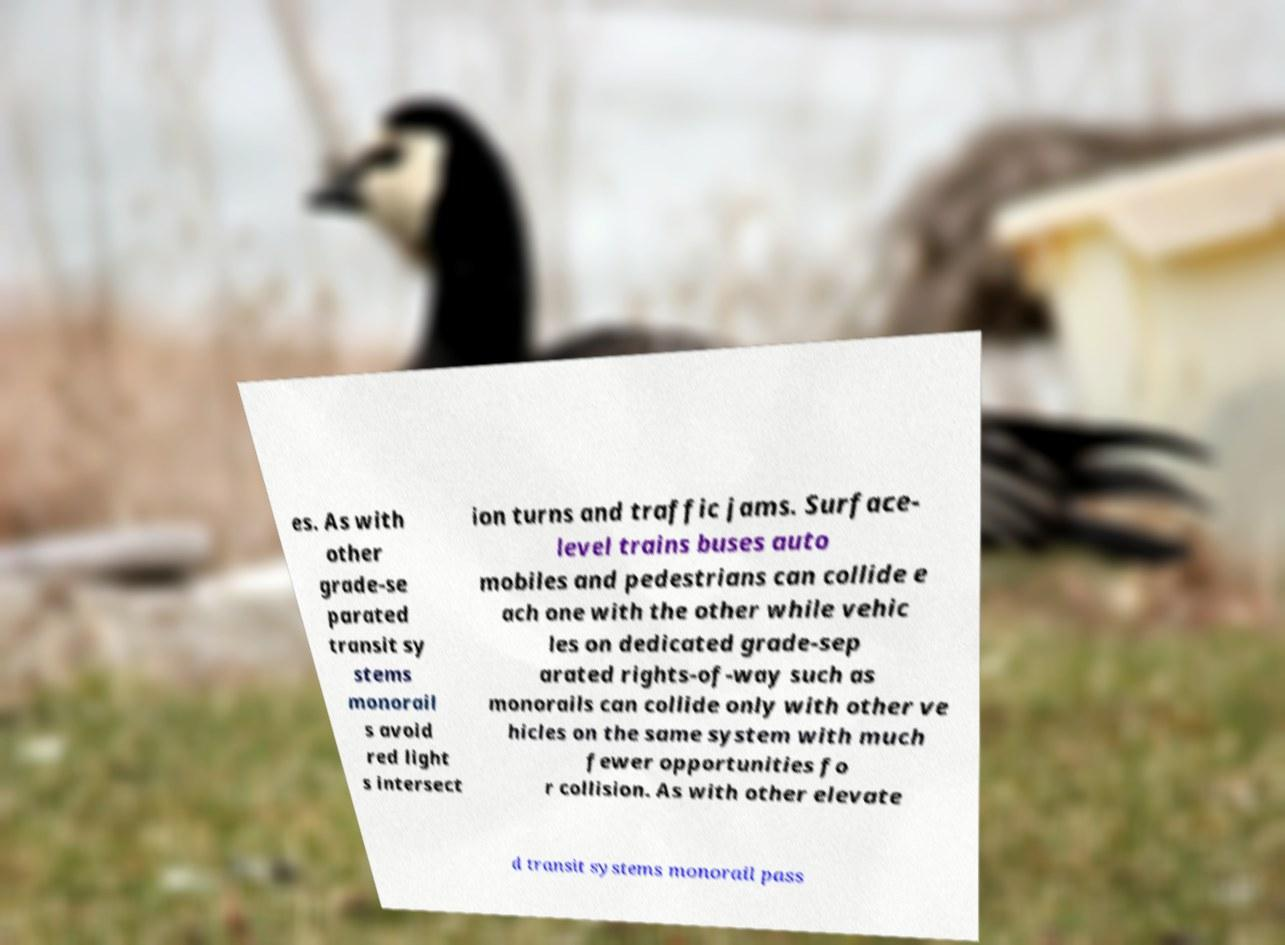For documentation purposes, I need the text within this image transcribed. Could you provide that? es. As with other grade-se parated transit sy stems monorail s avoid red light s intersect ion turns and traffic jams. Surface- level trains buses auto mobiles and pedestrians can collide e ach one with the other while vehic les on dedicated grade-sep arated rights-of-way such as monorails can collide only with other ve hicles on the same system with much fewer opportunities fo r collision. As with other elevate d transit systems monorail pass 